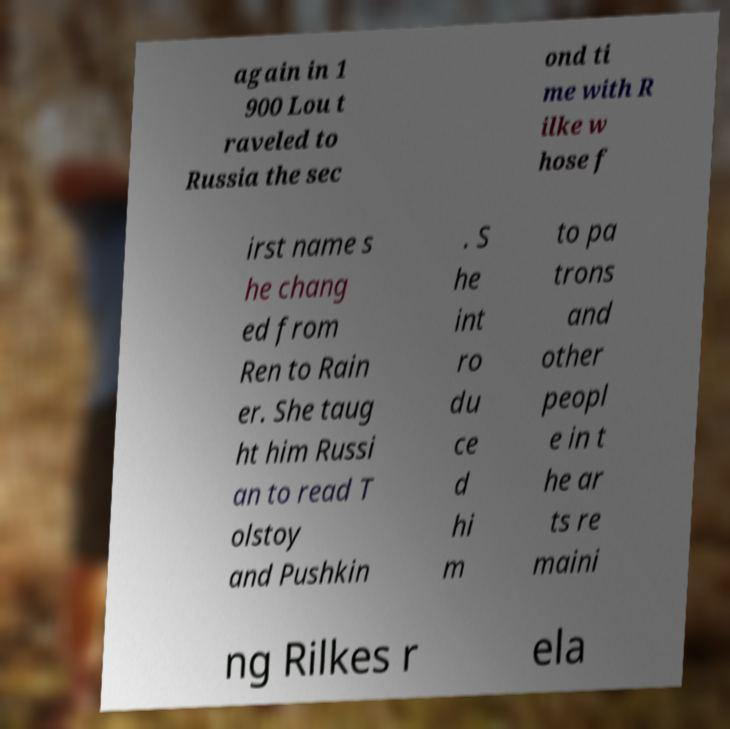I need the written content from this picture converted into text. Can you do that? again in 1 900 Lou t raveled to Russia the sec ond ti me with R ilke w hose f irst name s he chang ed from Ren to Rain er. She taug ht him Russi an to read T olstoy and Pushkin . S he int ro du ce d hi m to pa trons and other peopl e in t he ar ts re maini ng Rilkes r ela 